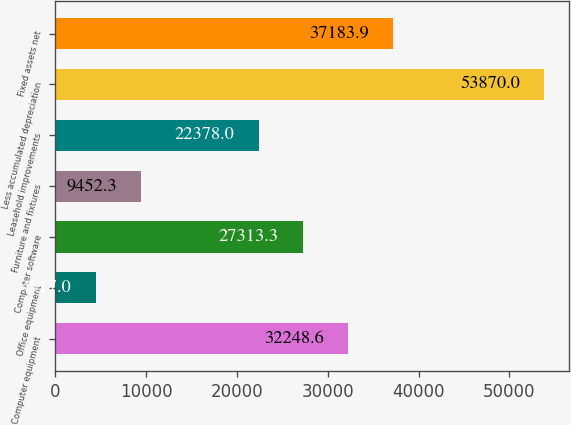Convert chart to OTSL. <chart><loc_0><loc_0><loc_500><loc_500><bar_chart><fcel>Computer equipment<fcel>Office equipment<fcel>Computer software<fcel>Furniture and fixtures<fcel>Leasehold improvements<fcel>Less accumulated depreciation<fcel>Fixed assets net<nl><fcel>32248.6<fcel>4517<fcel>27313.3<fcel>9452.3<fcel>22378<fcel>53870<fcel>37183.9<nl></chart> 